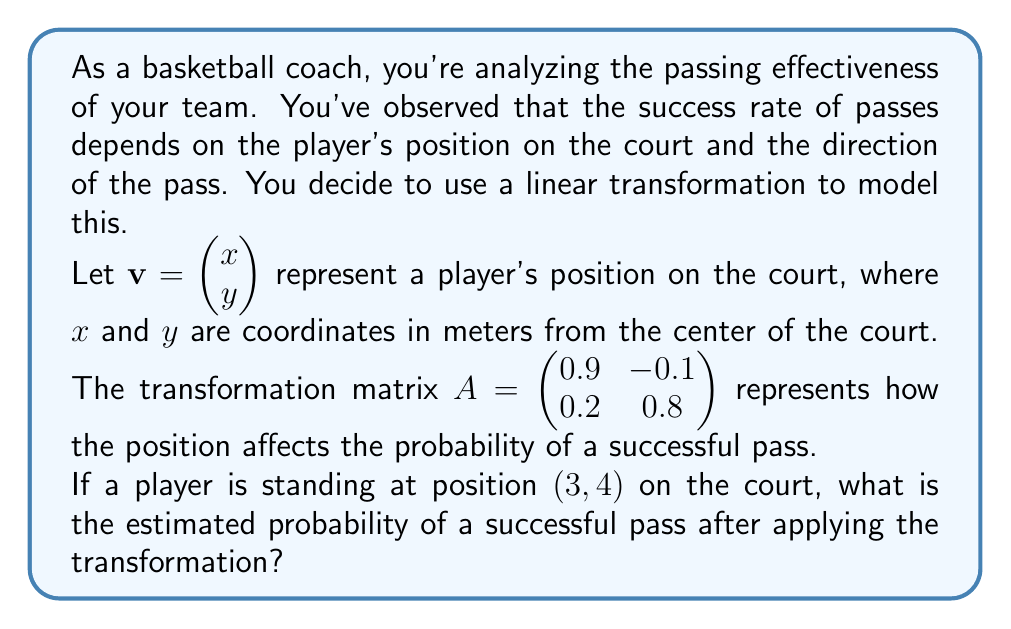Can you answer this question? Let's approach this step-by-step:

1) First, we need to create our position vector $\mathbf{v}$ based on the player's position:

   $\mathbf{v} = \begin{pmatrix} 3 \\ 4 \end{pmatrix}$

2) Now, we apply the linear transformation by multiplying the matrix $A$ with our vector $\mathbf{v}$:

   $A\mathbf{v} = \begin{pmatrix} 0.9 & -0.1 \\ 0.2 & 0.8 \end{pmatrix} \begin{pmatrix} 3 \\ 4 \end{pmatrix}$

3) Let's perform the matrix multiplication:

   $\begin{pmatrix} 0.9(3) + (-0.1)(4) \\ 0.2(3) + 0.8(4) \end{pmatrix}$

4) Simplify:

   $\begin{pmatrix} 2.7 - 0.4 \\ 0.6 + 3.2 \end{pmatrix} = \begin{pmatrix} 2.3 \\ 3.8 \end{pmatrix}$

5) The resulting vector represents the transformed position. To interpret this as a probability, we need to normalize it. We can do this by dividing each component by the sum of both components:

   Sum of components: $2.3 + 3.8 = 6.1$

   Normalized vector: $\frac{1}{6.1}\begin{pmatrix} 2.3 \\ 3.8 \end{pmatrix} = \begin{pmatrix} 0.377 \\ 0.623 \end{pmatrix}$

6) The second component of this normalized vector (0.623) represents our estimated probability of a successful pass.
Answer: The estimated probability of a successful pass is approximately 0.623 or 62.3%. 